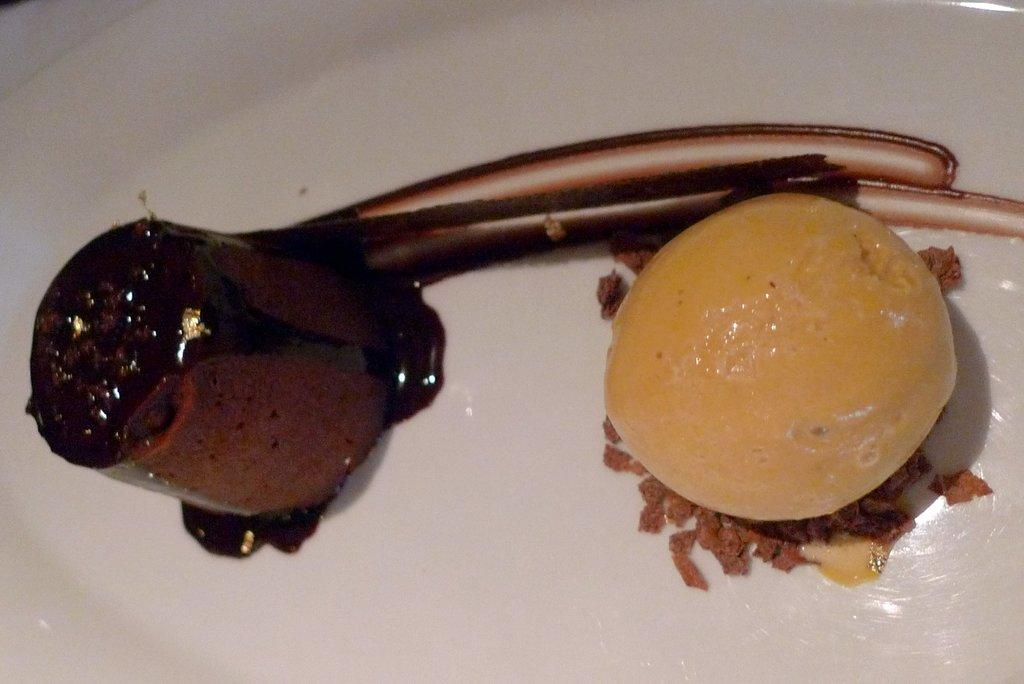What can be seen in the image? There are food items in the image. How are the food items arranged? The food items are placed on a white plate. What type of twig is being used by the father in the image? There is no father or twig present in the image; it only features food items on a white plate. 